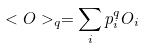Convert formula to latex. <formula><loc_0><loc_0><loc_500><loc_500>< O > _ { q } = \sum _ { i } p _ { i } ^ { q } O _ { i }</formula> 